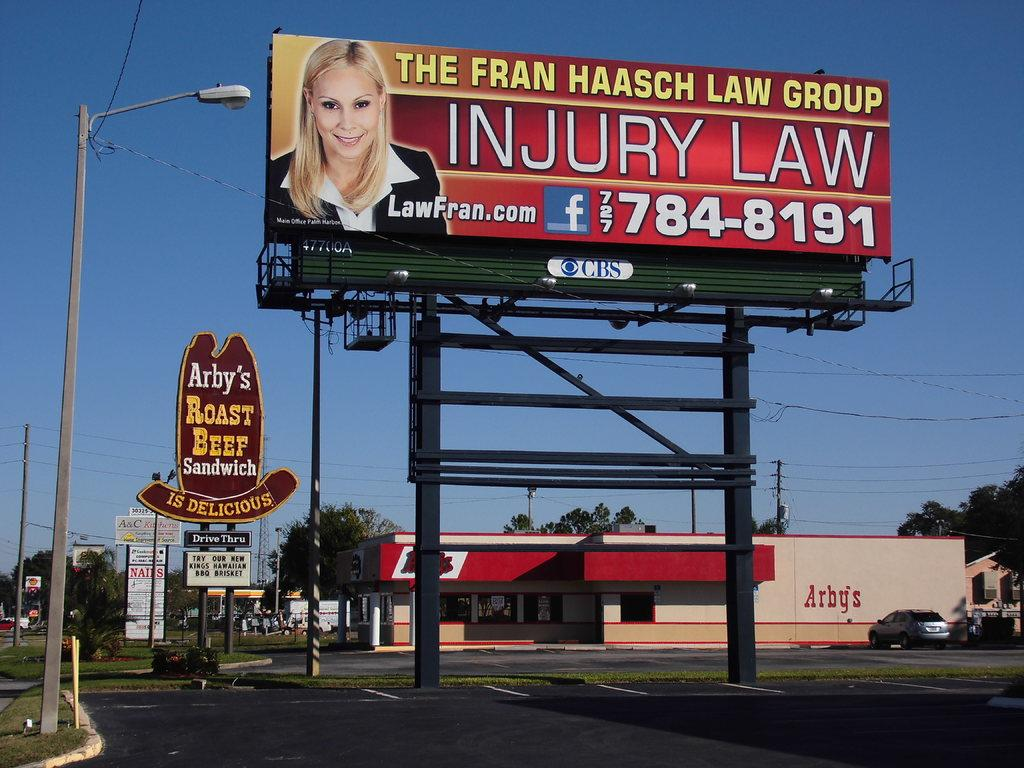Provide a one-sentence caption for the provided image. a billboard with a Arby's sign behind it. 